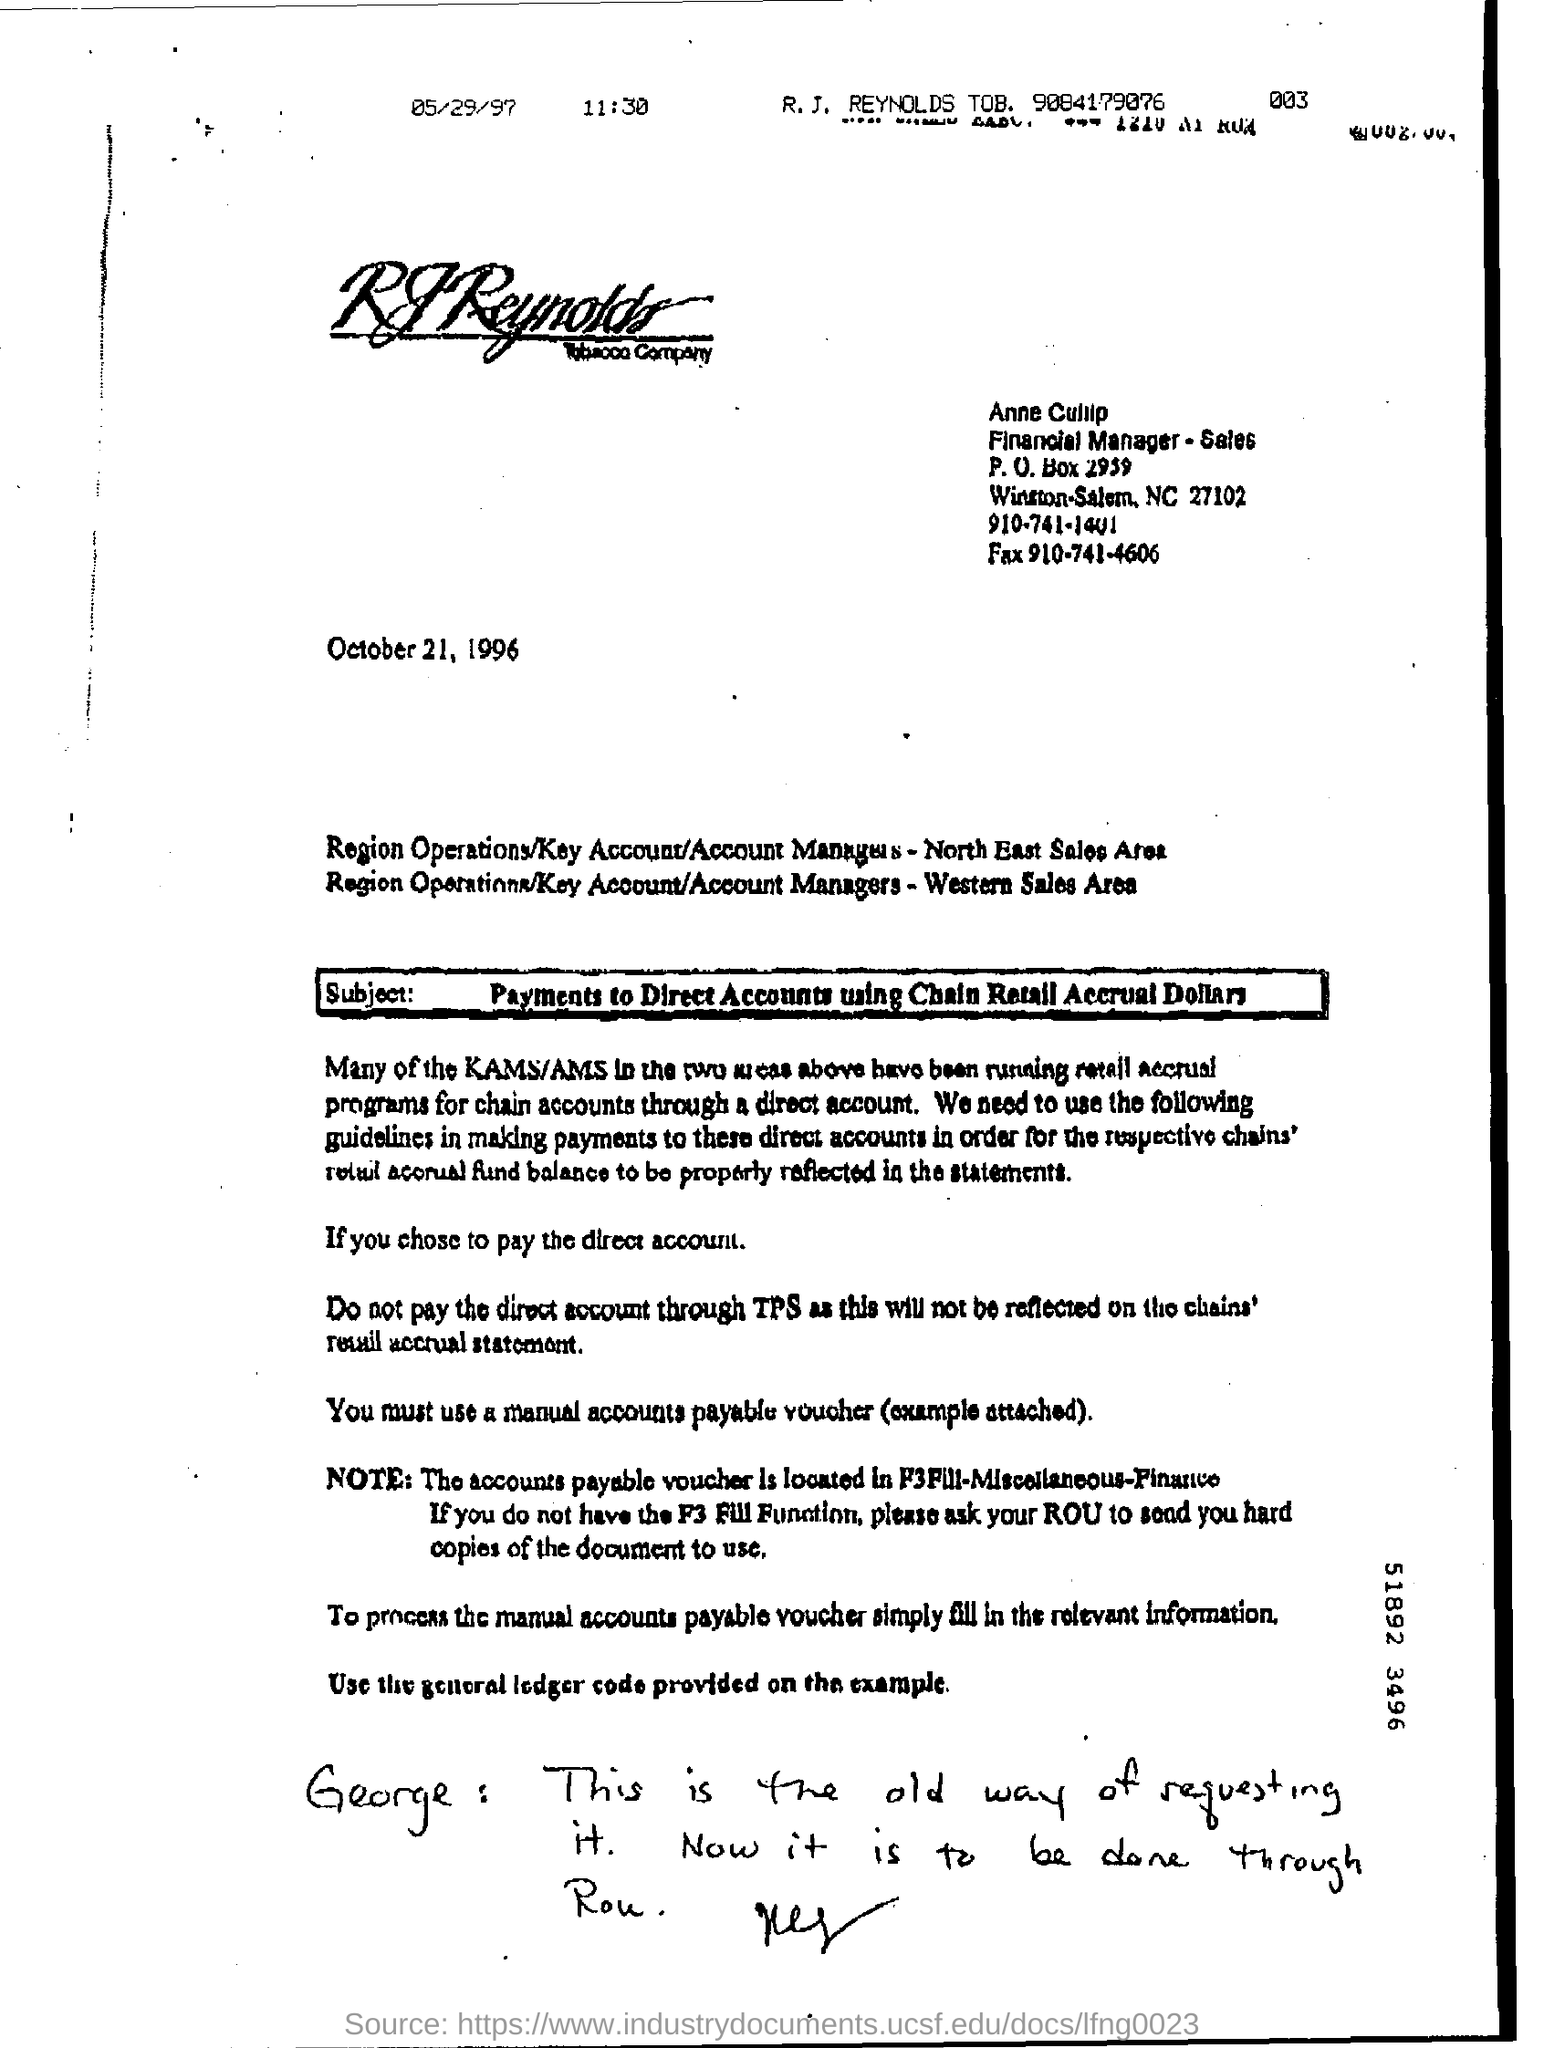Which company is mentioned in the letter head?
Provide a short and direct response. Tobacco. What is this letter dated?
Offer a terse response. October 21, 1996. What is the subject mentioned in this letter?
Your response must be concise. Payments to Direct Accounts using chain Retail Accrual Dollars. 